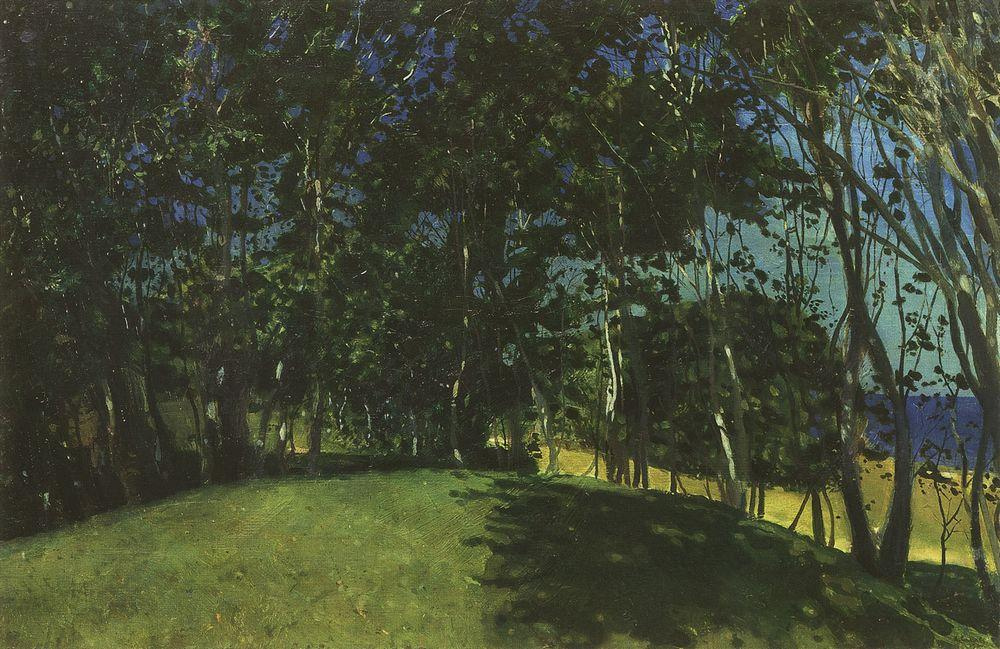What's happening in the scene? This image is an oil painting that captures a serene landscape scene. The artist has employed the impressionist style, characterized by visible brushstrokes and a loose, fluid style. The painting features a grove of trees, through which a path meanders. The colors used are predominantly green and blue, with the trees and foliage rendered in a darker green, and the sky and background in a lighter blue. The blending of these colors contributes to the peaceful and serene mood of the painting. The impressionist style and the choice of colors suggest that the artist may have been trying to capture the fleeting effects of light and color in the natural landscape. The overall composition and subject matter are reminiscent of the works of the Impressionist masters. 